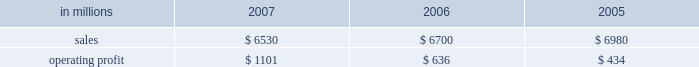Customer demand .
This compared with 555000 tons of total downtime in 2006 of which 150000 tons related to lack-of-orders .
Printing papers in millions 2007 2006 2005 .
North american printing papers net sales in 2007 were $ 3.5 billion compared with $ 4.4 billion in 2006 ( $ 3.5 billion excluding the coated and super- calendered papers business ) and $ 4.8 billion in 2005 ( $ 3.2 billion excluding the coated and super- calendered papers business ) .
Sales volumes decreased in 2007 versus 2006 partially due to reduced production capacity resulting from the conversion of the paper machine at the pensacola mill to the production of lightweight linerboard for our industrial packaging segment .
Average sales price realizations increased significantly , reflecting benefits from price increases announced throughout 2007 .
Lack-of-order downtime declined to 27000 tons in 2007 from 40000 tons in 2006 .
Operating earnings of $ 537 million in 2007 increased from $ 482 million in 2006 ( $ 407 million excluding the coated and supercalendered papers business ) and $ 175 million in 2005 ( $ 74 million excluding the coated and supercalendered papers business ) .
The benefits from improved average sales price realizations more than offset the effects of higher input costs for wood , energy , and freight .
Mill operations were favorable compared with the prior year due to current-year improvements in machine performance and energy conservation efforts .
Sales volumes for the first quarter of 2008 are expected to increase slightly , and the mix of prod- ucts sold to improve .
Demand for printing papers in north america was steady as the quarter began .
Price increases for cut-size paper and roll stock have been announced that are expected to be effective principally late in the first quarter .
Planned mill maintenance outage costs should be about the same as in the fourth quarter ; however , raw material costs are expected to continue to increase , primarily for wood and energy .
Brazil ian papers net sales for 2007 of $ 850 mil- lion were higher than the $ 495 million in 2006 and the $ 465 million in 2005 .
Compared with 2006 , aver- age sales price realizations improved reflecting price increases for uncoated freesheet paper realized dur- ing the second half of 2006 and the first half of 2007 .
Excluding the impact of the luiz antonio acquisition , sales volumes increased primarily for cut size and offset paper .
Operating profits for 2007 of $ 246 mil- lion were up from $ 122 million in 2006 and $ 134 mil- lion in 2005 as the benefits from higher sales prices and favorable manufacturing costs were only parti- ally offset by higher input costs .
Contributions from the luiz antonio acquisition increased net sales by approximately $ 350 million and earnings by approx- imately $ 80 million in 2007 .
Entering 2008 , sales volumes for uncoated freesheet paper and pulp should be seasonally lower .
Average price realizations should be essentially flat , but mar- gins are expected to reflect a less favorable product mix .
Energy costs , primarily for hydroelectric power , are expected to increase significantly reflecting a lack of rainfall in brazil in the latter part of 2007 .
European papers net sales in 2007 were $ 1.5 bil- lion compared with $ 1.3 billion in 2006 and $ 1.2 bil- lion in 2005 .
Sales volumes in 2007 were higher than in 2006 at our eastern european mills reflecting stronger market demand and improved efficiencies , but lower in western europe reflecting the closure of the marasquel mill in 2006 .
Average sales price real- izations increased significantly in 2007 in both east- ern and western european markets .
Operating profits of $ 214 million in 2007 increased from a loss of $ 16 million in 2006 and earnings of $ 88 million in 2005 .
The loss in 2006 reflects the impact of a $ 128 million impairment charge to reduce the carrying value of the fixed assets at the saillat , france mill .
Excluding this charge , the improvement in 2007 compared with 2006 reflects the contribution from higher net sales , partially offset by higher input costs for wood , energy and freight .
Looking ahead to the first quarter of 2008 , sales volumes are expected to be stable in western europe , but seasonally weaker in eastern europe and russia .
Average price realizations are expected to remain about flat .
Wood costs are expected to increase , especially in russia due to strong demand ahead of tariff increases , and energy costs are anticipated to be seasonally higher .
Asian printing papers net sales were approx- imately $ 20 million in 2007 , compared with $ 15 mil- lion in 2006 and $ 10 million in 2005 .
Operating earnings increased slightly in 2007 , but were close to breakeven in all periods .
U.s .
Market pulp sales in 2007 totaled $ 655 mil- lion compared with $ 510 million and $ 525 million in 2006 and 2005 , respectively .
Sales volumes in 2007 were up from 2006 levels , primarily for paper and .
What percent of printing papers sales in 2006 was from north american printing papers net sales? 
Computations: ((4.4 * 1000) / 6700)
Answer: 0.65672. 